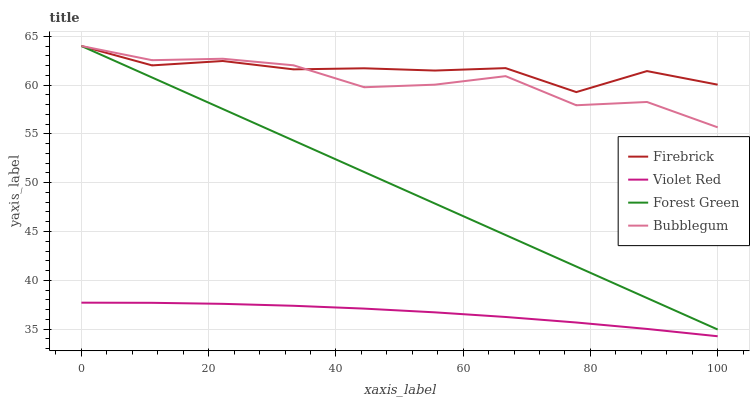Does Violet Red have the minimum area under the curve?
Answer yes or no. Yes. Does Firebrick have the maximum area under the curve?
Answer yes or no. Yes. Does Firebrick have the minimum area under the curve?
Answer yes or no. No. Does Violet Red have the maximum area under the curve?
Answer yes or no. No. Is Forest Green the smoothest?
Answer yes or no. Yes. Is Bubblegum the roughest?
Answer yes or no. Yes. Is Firebrick the smoothest?
Answer yes or no. No. Is Firebrick the roughest?
Answer yes or no. No. Does Violet Red have the lowest value?
Answer yes or no. Yes. Does Firebrick have the lowest value?
Answer yes or no. No. Does Bubblegum have the highest value?
Answer yes or no. Yes. Does Violet Red have the highest value?
Answer yes or no. No. Is Violet Red less than Firebrick?
Answer yes or no. Yes. Is Forest Green greater than Violet Red?
Answer yes or no. Yes. Does Forest Green intersect Firebrick?
Answer yes or no. Yes. Is Forest Green less than Firebrick?
Answer yes or no. No. Is Forest Green greater than Firebrick?
Answer yes or no. No. Does Violet Red intersect Firebrick?
Answer yes or no. No. 